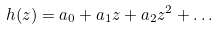<formula> <loc_0><loc_0><loc_500><loc_500>h ( z ) = a _ { 0 } + a _ { 1 } z + a _ { 2 } z ^ { 2 } + \dots</formula> 